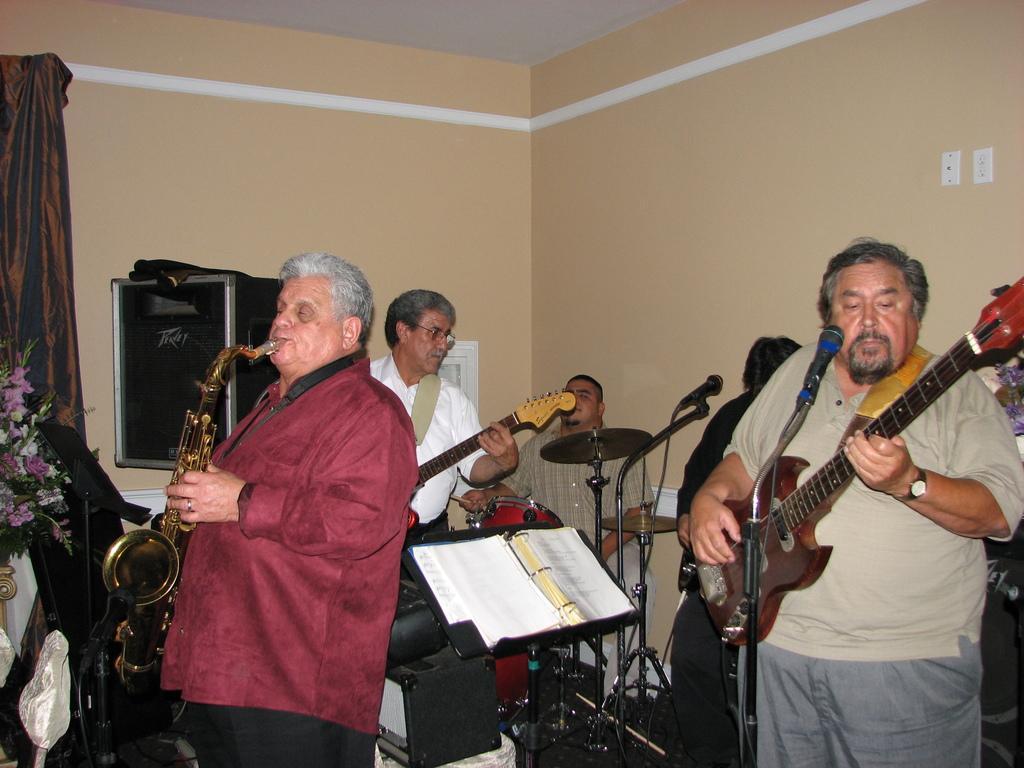Describe this image in one or two sentences. This picture is clicked in the room where there are musicians performing. At the right side the man is standing and holding a guitar in his hand. In the center the man is sitting and playing drums. At the left side man is standing and holding a musical instrument and playing. In the background there is a brown colour curtain and flowers. 